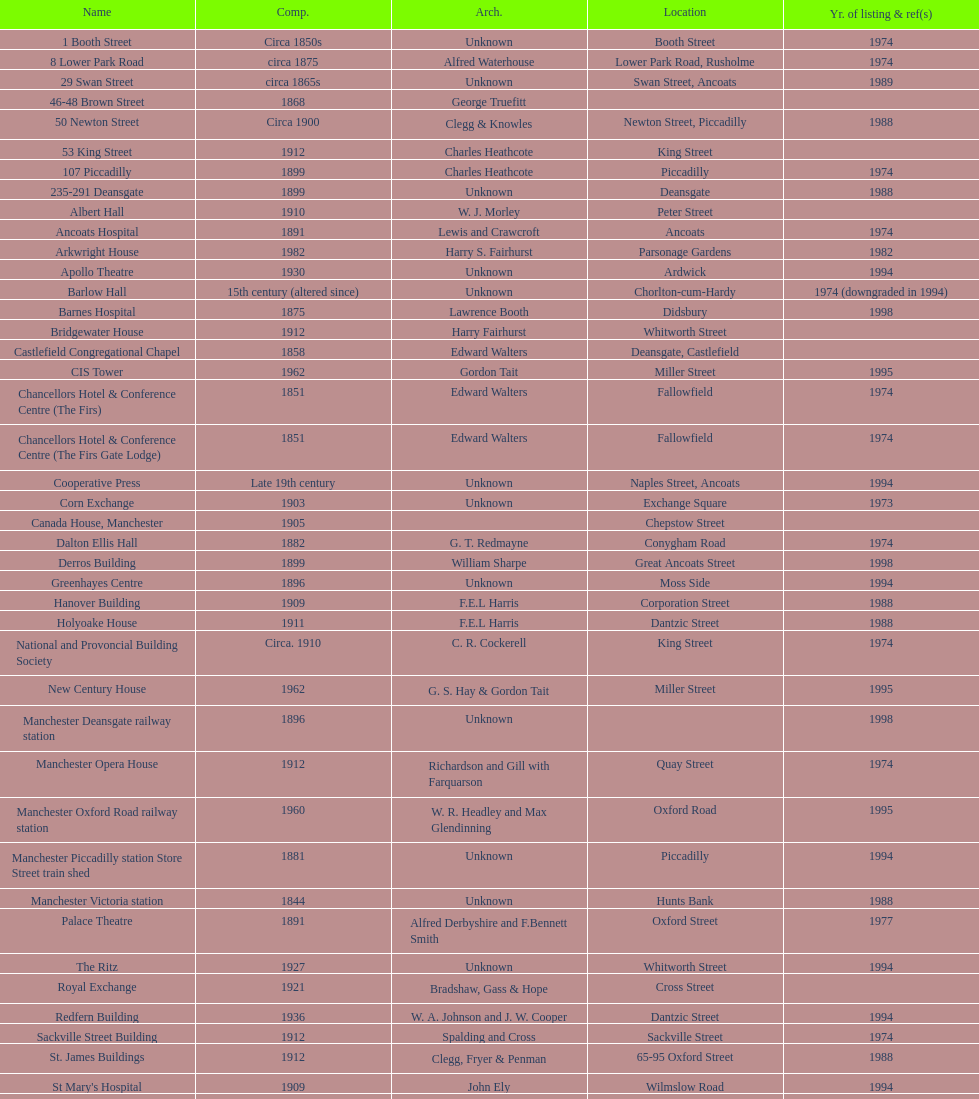How many names are listed with an image? 39. 